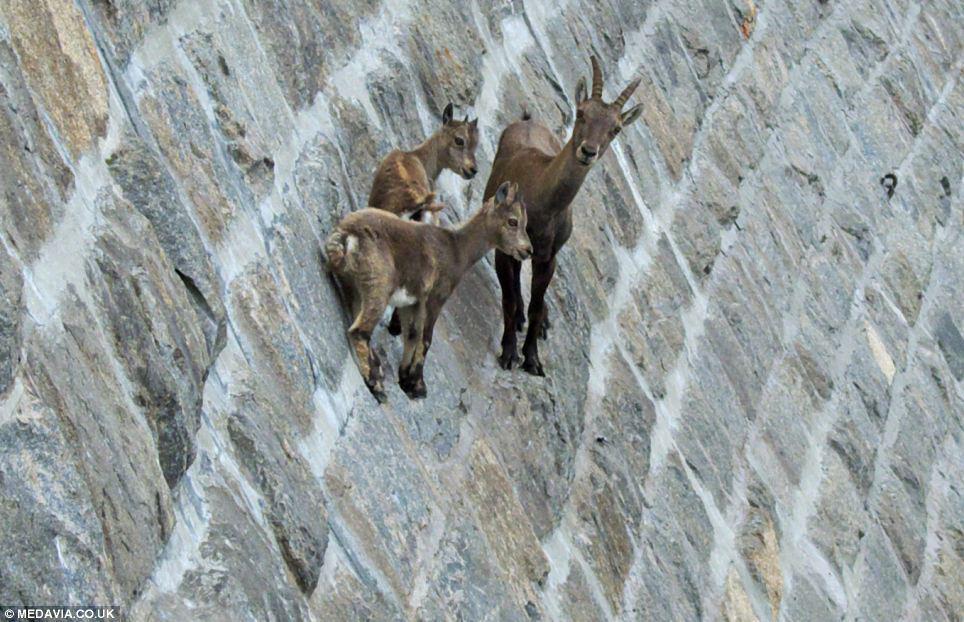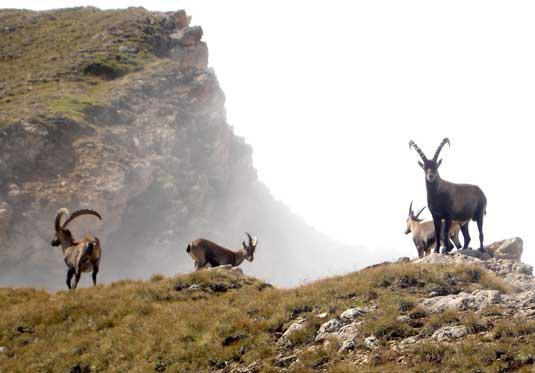The first image is the image on the left, the second image is the image on the right. For the images displayed, is the sentence "There is only one antelope in one of the images" factually correct? Answer yes or no. No. The first image is the image on the left, the second image is the image on the right. Assess this claim about the two images: "An image shows no more than two goats standing on a rock peak.". Correct or not? Answer yes or no. No. 